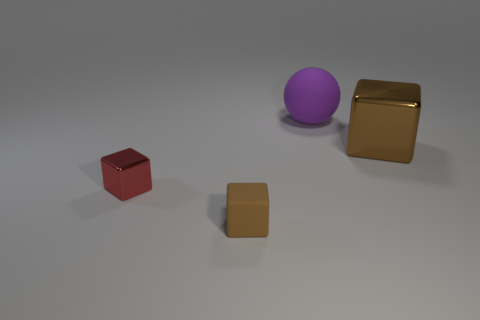There is a red thing that is the same shape as the brown metallic object; what is it made of?
Make the answer very short. Metal. Is the color of the block that is on the right side of the small brown rubber cube the same as the small cube that is right of the tiny red metal thing?
Provide a succinct answer. Yes. There is a brown thing behind the small red metal cube; what is its material?
Provide a short and direct response. Metal. What color is the tiny object that is the same material as the ball?
Keep it short and to the point. Brown. What number of other things have the same size as the brown metallic thing?
Ensure brevity in your answer.  1. There is a brown thing on the left side of the purple rubber ball; does it have the same size as the tiny metallic block?
Offer a terse response. Yes. There is a thing that is right of the tiny brown block and in front of the sphere; what shape is it?
Keep it short and to the point. Cube. Are there any large purple rubber objects behind the small brown rubber block?
Make the answer very short. Yes. Are there any other things that have the same shape as the large rubber thing?
Your answer should be compact. No. Do the tiny brown matte object and the brown shiny object have the same shape?
Ensure brevity in your answer.  Yes. 